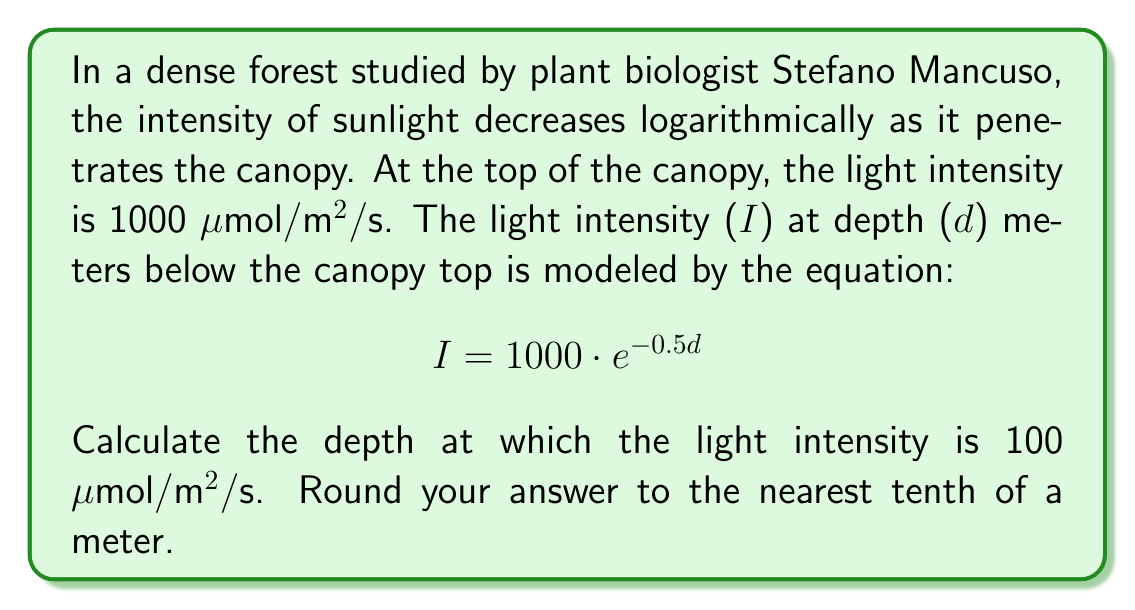Show me your answer to this math problem. Let's approach this step-by-step:

1) We're given the equation $$I = 1000 \cdot e^{-0.5d}$$
   where I is the light intensity and d is the depth.

2) We want to find d when I = 100 μmol/m²/s. Let's substitute this:

   $$100 = 1000 \cdot e^{-0.5d}$$

3) Divide both sides by 1000:

   $$0.1 = e^{-0.5d}$$

4) Take the natural logarithm of both sides:

   $$\ln(0.1) = \ln(e^{-0.5d})$$

5) The right side simplifies due to the properties of logarithms:

   $$\ln(0.1) = -0.5d$$

6) Divide both sides by -0.5:

   $$\frac{\ln(0.1)}{-0.5} = d$$

7) Calculate:
   
   $$d = \frac{\ln(0.1)}{-0.5} \approx 4.6052$$

8) Rounding to the nearest tenth:

   $$d \approx 4.6 \text{ meters}$$
Answer: 4.6 meters 